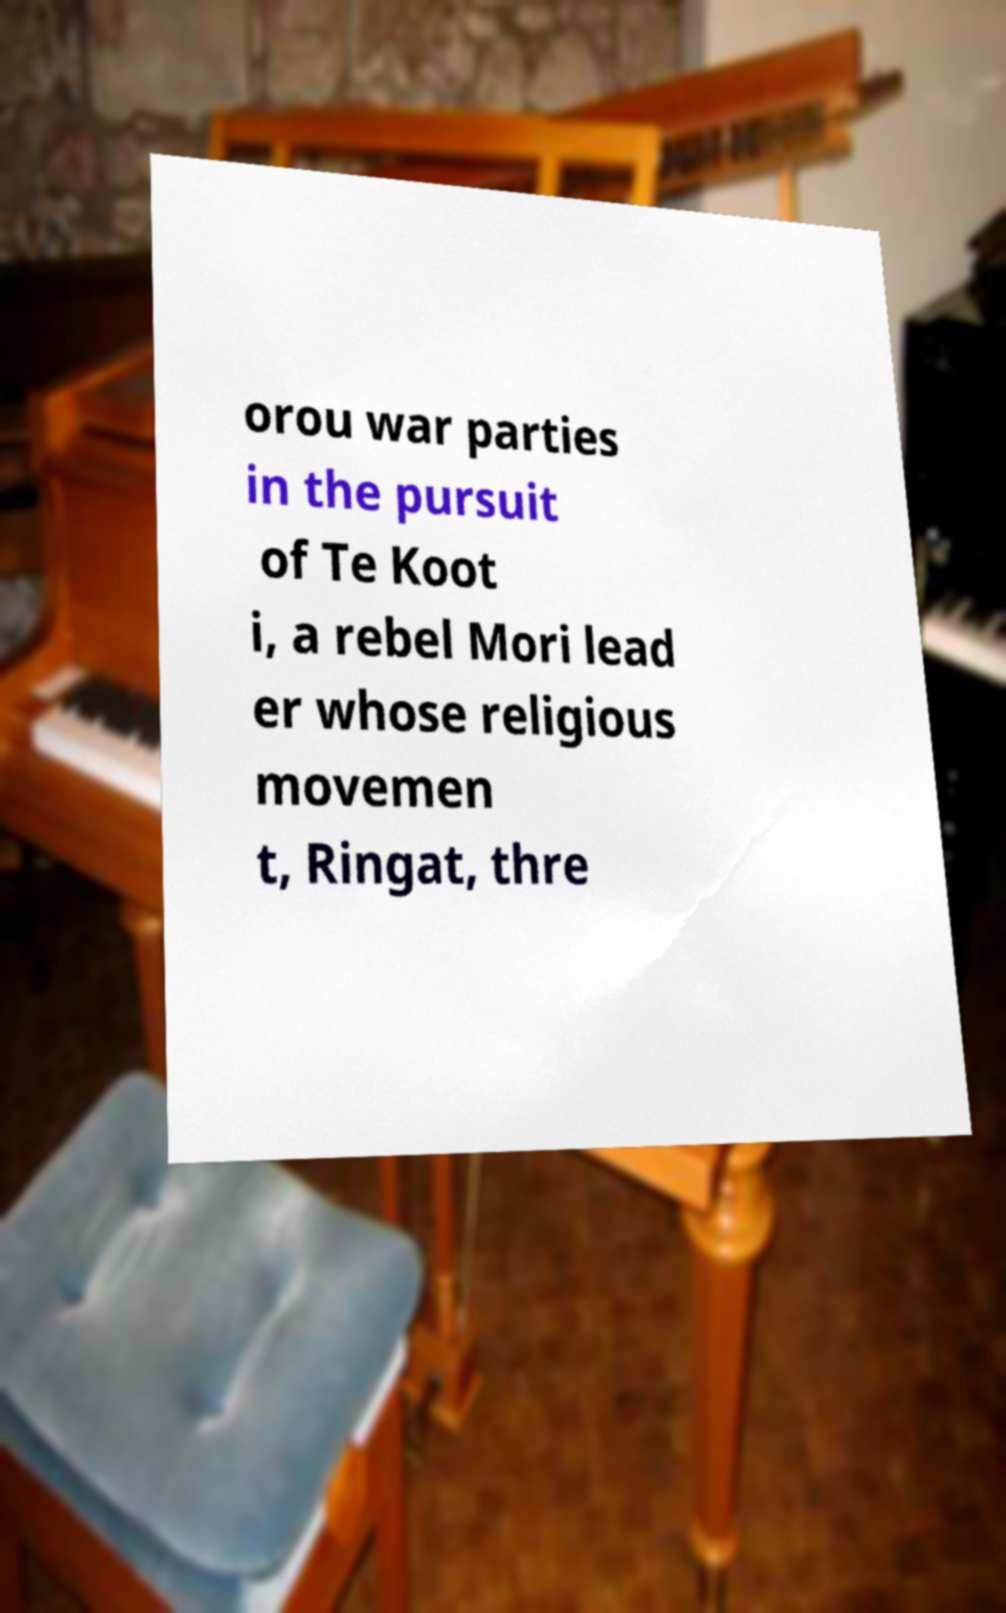Can you read and provide the text displayed in the image?This photo seems to have some interesting text. Can you extract and type it out for me? orou war parties in the pursuit of Te Koot i, a rebel Mori lead er whose religious movemen t, Ringat, thre 